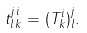Convert formula to latex. <formula><loc_0><loc_0><loc_500><loc_500>t ^ { j \, i } _ { l \, k } = ( T ^ { i } _ { k } ) ^ { j } _ { l } .</formula> 